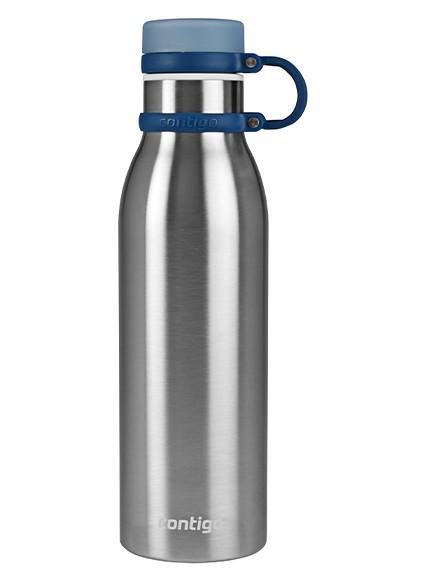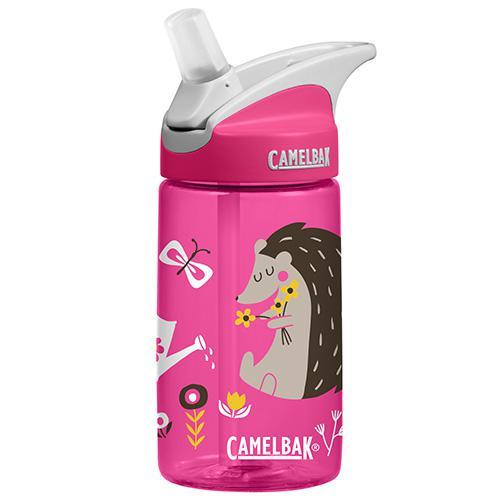The first image is the image on the left, the second image is the image on the right. Analyze the images presented: Is the assertion "At least one of the bottles in the image is pink." valid? Answer yes or no. Yes. 